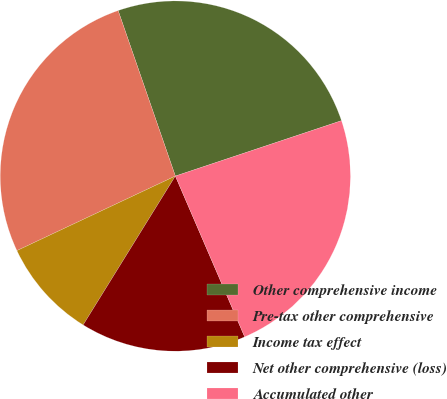Convert chart. <chart><loc_0><loc_0><loc_500><loc_500><pie_chart><fcel>Other comprehensive income<fcel>Pre-tax other comprehensive<fcel>Income tax effect<fcel>Net other comprehensive (loss)<fcel>Accumulated other<nl><fcel>25.17%<fcel>26.7%<fcel>9.17%<fcel>15.3%<fcel>23.64%<nl></chart> 